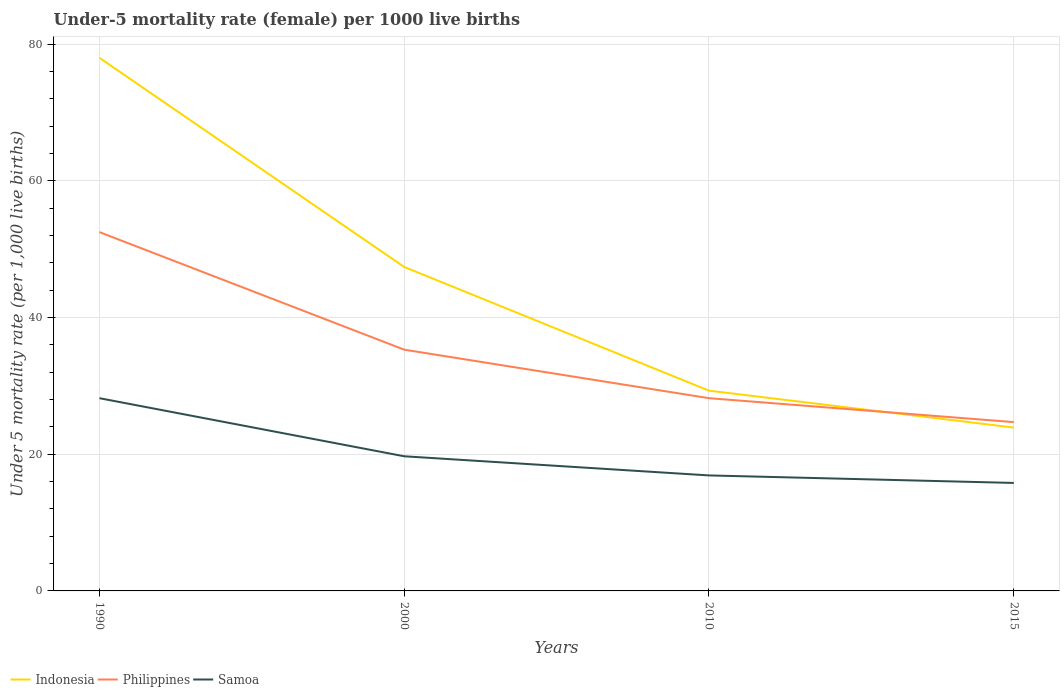How many different coloured lines are there?
Provide a short and direct response. 3. Is the number of lines equal to the number of legend labels?
Your response must be concise. Yes. Across all years, what is the maximum under-five mortality rate in Philippines?
Your response must be concise. 24.7. In which year was the under-five mortality rate in Samoa maximum?
Make the answer very short. 2015. What is the total under-five mortality rate in Indonesia in the graph?
Your answer should be compact. 48.7. What is the difference between the highest and the second highest under-five mortality rate in Samoa?
Your answer should be very brief. 12.4. What is the difference between the highest and the lowest under-five mortality rate in Indonesia?
Make the answer very short. 2. How many lines are there?
Your response must be concise. 3. How many years are there in the graph?
Offer a very short reply. 4. What is the difference between two consecutive major ticks on the Y-axis?
Your answer should be very brief. 20. Where does the legend appear in the graph?
Offer a very short reply. Bottom left. How are the legend labels stacked?
Give a very brief answer. Horizontal. What is the title of the graph?
Ensure brevity in your answer.  Under-5 mortality rate (female) per 1000 live births. What is the label or title of the Y-axis?
Ensure brevity in your answer.  Under 5 mortality rate (per 1,0 live births). What is the Under 5 mortality rate (per 1,000 live births) of Indonesia in 1990?
Your answer should be very brief. 78. What is the Under 5 mortality rate (per 1,000 live births) in Philippines in 1990?
Give a very brief answer. 52.5. What is the Under 5 mortality rate (per 1,000 live births) of Samoa in 1990?
Offer a terse response. 28.2. What is the Under 5 mortality rate (per 1,000 live births) of Indonesia in 2000?
Offer a very short reply. 47.4. What is the Under 5 mortality rate (per 1,000 live births) of Philippines in 2000?
Provide a short and direct response. 35.3. What is the Under 5 mortality rate (per 1,000 live births) in Samoa in 2000?
Offer a terse response. 19.7. What is the Under 5 mortality rate (per 1,000 live births) of Indonesia in 2010?
Provide a short and direct response. 29.3. What is the Under 5 mortality rate (per 1,000 live births) of Philippines in 2010?
Offer a very short reply. 28.2. What is the Under 5 mortality rate (per 1,000 live births) of Indonesia in 2015?
Give a very brief answer. 23.9. What is the Under 5 mortality rate (per 1,000 live births) in Philippines in 2015?
Provide a succinct answer. 24.7. What is the Under 5 mortality rate (per 1,000 live births) in Samoa in 2015?
Your answer should be very brief. 15.8. Across all years, what is the maximum Under 5 mortality rate (per 1,000 live births) in Indonesia?
Your answer should be very brief. 78. Across all years, what is the maximum Under 5 mortality rate (per 1,000 live births) in Philippines?
Your answer should be very brief. 52.5. Across all years, what is the maximum Under 5 mortality rate (per 1,000 live births) of Samoa?
Provide a short and direct response. 28.2. Across all years, what is the minimum Under 5 mortality rate (per 1,000 live births) in Indonesia?
Provide a short and direct response. 23.9. Across all years, what is the minimum Under 5 mortality rate (per 1,000 live births) of Philippines?
Offer a very short reply. 24.7. Across all years, what is the minimum Under 5 mortality rate (per 1,000 live births) of Samoa?
Make the answer very short. 15.8. What is the total Under 5 mortality rate (per 1,000 live births) of Indonesia in the graph?
Keep it short and to the point. 178.6. What is the total Under 5 mortality rate (per 1,000 live births) of Philippines in the graph?
Your response must be concise. 140.7. What is the total Under 5 mortality rate (per 1,000 live births) in Samoa in the graph?
Make the answer very short. 80.6. What is the difference between the Under 5 mortality rate (per 1,000 live births) of Indonesia in 1990 and that in 2000?
Offer a terse response. 30.6. What is the difference between the Under 5 mortality rate (per 1,000 live births) in Philippines in 1990 and that in 2000?
Your response must be concise. 17.2. What is the difference between the Under 5 mortality rate (per 1,000 live births) of Samoa in 1990 and that in 2000?
Your response must be concise. 8.5. What is the difference between the Under 5 mortality rate (per 1,000 live births) of Indonesia in 1990 and that in 2010?
Ensure brevity in your answer.  48.7. What is the difference between the Under 5 mortality rate (per 1,000 live births) in Philippines in 1990 and that in 2010?
Offer a very short reply. 24.3. What is the difference between the Under 5 mortality rate (per 1,000 live births) of Indonesia in 1990 and that in 2015?
Offer a terse response. 54.1. What is the difference between the Under 5 mortality rate (per 1,000 live births) in Philippines in 1990 and that in 2015?
Provide a short and direct response. 27.8. What is the difference between the Under 5 mortality rate (per 1,000 live births) in Samoa in 1990 and that in 2015?
Make the answer very short. 12.4. What is the difference between the Under 5 mortality rate (per 1,000 live births) in Philippines in 2000 and that in 2010?
Give a very brief answer. 7.1. What is the difference between the Under 5 mortality rate (per 1,000 live births) in Samoa in 2000 and that in 2010?
Your response must be concise. 2.8. What is the difference between the Under 5 mortality rate (per 1,000 live births) in Indonesia in 2010 and that in 2015?
Your answer should be compact. 5.4. What is the difference between the Under 5 mortality rate (per 1,000 live births) in Philippines in 2010 and that in 2015?
Ensure brevity in your answer.  3.5. What is the difference between the Under 5 mortality rate (per 1,000 live births) in Indonesia in 1990 and the Under 5 mortality rate (per 1,000 live births) in Philippines in 2000?
Make the answer very short. 42.7. What is the difference between the Under 5 mortality rate (per 1,000 live births) of Indonesia in 1990 and the Under 5 mortality rate (per 1,000 live births) of Samoa in 2000?
Your answer should be very brief. 58.3. What is the difference between the Under 5 mortality rate (per 1,000 live births) of Philippines in 1990 and the Under 5 mortality rate (per 1,000 live births) of Samoa in 2000?
Give a very brief answer. 32.8. What is the difference between the Under 5 mortality rate (per 1,000 live births) in Indonesia in 1990 and the Under 5 mortality rate (per 1,000 live births) in Philippines in 2010?
Ensure brevity in your answer.  49.8. What is the difference between the Under 5 mortality rate (per 1,000 live births) of Indonesia in 1990 and the Under 5 mortality rate (per 1,000 live births) of Samoa in 2010?
Offer a terse response. 61.1. What is the difference between the Under 5 mortality rate (per 1,000 live births) of Philippines in 1990 and the Under 5 mortality rate (per 1,000 live births) of Samoa in 2010?
Give a very brief answer. 35.6. What is the difference between the Under 5 mortality rate (per 1,000 live births) of Indonesia in 1990 and the Under 5 mortality rate (per 1,000 live births) of Philippines in 2015?
Give a very brief answer. 53.3. What is the difference between the Under 5 mortality rate (per 1,000 live births) in Indonesia in 1990 and the Under 5 mortality rate (per 1,000 live births) in Samoa in 2015?
Provide a short and direct response. 62.2. What is the difference between the Under 5 mortality rate (per 1,000 live births) of Philippines in 1990 and the Under 5 mortality rate (per 1,000 live births) of Samoa in 2015?
Offer a terse response. 36.7. What is the difference between the Under 5 mortality rate (per 1,000 live births) of Indonesia in 2000 and the Under 5 mortality rate (per 1,000 live births) of Philippines in 2010?
Your response must be concise. 19.2. What is the difference between the Under 5 mortality rate (per 1,000 live births) in Indonesia in 2000 and the Under 5 mortality rate (per 1,000 live births) in Samoa in 2010?
Offer a very short reply. 30.5. What is the difference between the Under 5 mortality rate (per 1,000 live births) of Philippines in 2000 and the Under 5 mortality rate (per 1,000 live births) of Samoa in 2010?
Provide a succinct answer. 18.4. What is the difference between the Under 5 mortality rate (per 1,000 live births) in Indonesia in 2000 and the Under 5 mortality rate (per 1,000 live births) in Philippines in 2015?
Ensure brevity in your answer.  22.7. What is the difference between the Under 5 mortality rate (per 1,000 live births) in Indonesia in 2000 and the Under 5 mortality rate (per 1,000 live births) in Samoa in 2015?
Provide a short and direct response. 31.6. What is the difference between the Under 5 mortality rate (per 1,000 live births) of Philippines in 2000 and the Under 5 mortality rate (per 1,000 live births) of Samoa in 2015?
Provide a short and direct response. 19.5. What is the difference between the Under 5 mortality rate (per 1,000 live births) of Indonesia in 2010 and the Under 5 mortality rate (per 1,000 live births) of Philippines in 2015?
Keep it short and to the point. 4.6. What is the average Under 5 mortality rate (per 1,000 live births) in Indonesia per year?
Give a very brief answer. 44.65. What is the average Under 5 mortality rate (per 1,000 live births) of Philippines per year?
Offer a very short reply. 35.17. What is the average Under 5 mortality rate (per 1,000 live births) of Samoa per year?
Provide a succinct answer. 20.15. In the year 1990, what is the difference between the Under 5 mortality rate (per 1,000 live births) of Indonesia and Under 5 mortality rate (per 1,000 live births) of Philippines?
Offer a terse response. 25.5. In the year 1990, what is the difference between the Under 5 mortality rate (per 1,000 live births) of Indonesia and Under 5 mortality rate (per 1,000 live births) of Samoa?
Provide a succinct answer. 49.8. In the year 1990, what is the difference between the Under 5 mortality rate (per 1,000 live births) of Philippines and Under 5 mortality rate (per 1,000 live births) of Samoa?
Provide a short and direct response. 24.3. In the year 2000, what is the difference between the Under 5 mortality rate (per 1,000 live births) in Indonesia and Under 5 mortality rate (per 1,000 live births) in Samoa?
Your answer should be compact. 27.7. In the year 2000, what is the difference between the Under 5 mortality rate (per 1,000 live births) in Philippines and Under 5 mortality rate (per 1,000 live births) in Samoa?
Keep it short and to the point. 15.6. In the year 2010, what is the difference between the Under 5 mortality rate (per 1,000 live births) of Indonesia and Under 5 mortality rate (per 1,000 live births) of Samoa?
Your answer should be compact. 12.4. In the year 2015, what is the difference between the Under 5 mortality rate (per 1,000 live births) of Indonesia and Under 5 mortality rate (per 1,000 live births) of Philippines?
Your answer should be compact. -0.8. In the year 2015, what is the difference between the Under 5 mortality rate (per 1,000 live births) of Indonesia and Under 5 mortality rate (per 1,000 live births) of Samoa?
Your response must be concise. 8.1. In the year 2015, what is the difference between the Under 5 mortality rate (per 1,000 live births) of Philippines and Under 5 mortality rate (per 1,000 live births) of Samoa?
Provide a short and direct response. 8.9. What is the ratio of the Under 5 mortality rate (per 1,000 live births) of Indonesia in 1990 to that in 2000?
Offer a terse response. 1.65. What is the ratio of the Under 5 mortality rate (per 1,000 live births) in Philippines in 1990 to that in 2000?
Offer a very short reply. 1.49. What is the ratio of the Under 5 mortality rate (per 1,000 live births) in Samoa in 1990 to that in 2000?
Offer a very short reply. 1.43. What is the ratio of the Under 5 mortality rate (per 1,000 live births) of Indonesia in 1990 to that in 2010?
Provide a succinct answer. 2.66. What is the ratio of the Under 5 mortality rate (per 1,000 live births) of Philippines in 1990 to that in 2010?
Ensure brevity in your answer.  1.86. What is the ratio of the Under 5 mortality rate (per 1,000 live births) in Samoa in 1990 to that in 2010?
Your answer should be compact. 1.67. What is the ratio of the Under 5 mortality rate (per 1,000 live births) of Indonesia in 1990 to that in 2015?
Offer a terse response. 3.26. What is the ratio of the Under 5 mortality rate (per 1,000 live births) of Philippines in 1990 to that in 2015?
Offer a very short reply. 2.13. What is the ratio of the Under 5 mortality rate (per 1,000 live births) in Samoa in 1990 to that in 2015?
Offer a terse response. 1.78. What is the ratio of the Under 5 mortality rate (per 1,000 live births) of Indonesia in 2000 to that in 2010?
Your answer should be very brief. 1.62. What is the ratio of the Under 5 mortality rate (per 1,000 live births) in Philippines in 2000 to that in 2010?
Your answer should be very brief. 1.25. What is the ratio of the Under 5 mortality rate (per 1,000 live births) of Samoa in 2000 to that in 2010?
Ensure brevity in your answer.  1.17. What is the ratio of the Under 5 mortality rate (per 1,000 live births) of Indonesia in 2000 to that in 2015?
Your answer should be very brief. 1.98. What is the ratio of the Under 5 mortality rate (per 1,000 live births) in Philippines in 2000 to that in 2015?
Make the answer very short. 1.43. What is the ratio of the Under 5 mortality rate (per 1,000 live births) in Samoa in 2000 to that in 2015?
Your answer should be very brief. 1.25. What is the ratio of the Under 5 mortality rate (per 1,000 live births) of Indonesia in 2010 to that in 2015?
Give a very brief answer. 1.23. What is the ratio of the Under 5 mortality rate (per 1,000 live births) of Philippines in 2010 to that in 2015?
Make the answer very short. 1.14. What is the ratio of the Under 5 mortality rate (per 1,000 live births) of Samoa in 2010 to that in 2015?
Provide a short and direct response. 1.07. What is the difference between the highest and the second highest Under 5 mortality rate (per 1,000 live births) of Indonesia?
Keep it short and to the point. 30.6. What is the difference between the highest and the second highest Under 5 mortality rate (per 1,000 live births) in Samoa?
Ensure brevity in your answer.  8.5. What is the difference between the highest and the lowest Under 5 mortality rate (per 1,000 live births) in Indonesia?
Give a very brief answer. 54.1. What is the difference between the highest and the lowest Under 5 mortality rate (per 1,000 live births) of Philippines?
Your answer should be compact. 27.8. What is the difference between the highest and the lowest Under 5 mortality rate (per 1,000 live births) of Samoa?
Offer a very short reply. 12.4. 